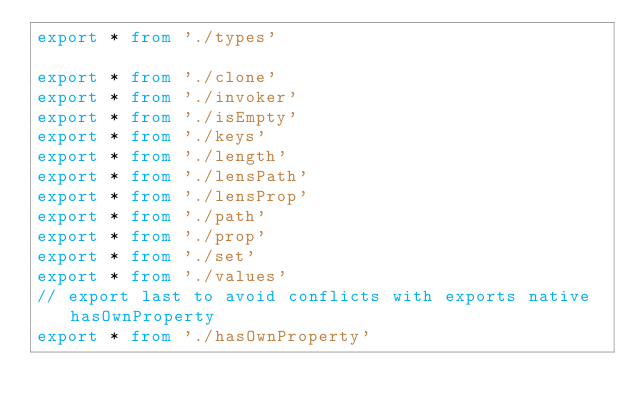Convert code to text. <code><loc_0><loc_0><loc_500><loc_500><_TypeScript_>export * from './types'

export * from './clone'
export * from './invoker'
export * from './isEmpty'
export * from './keys'
export * from './length'
export * from './lensPath'
export * from './lensProp'
export * from './path'
export * from './prop'
export * from './set'
export * from './values'
// export last to avoid conflicts with exports native hasOwnProperty
export * from './hasOwnProperty'
</code> 